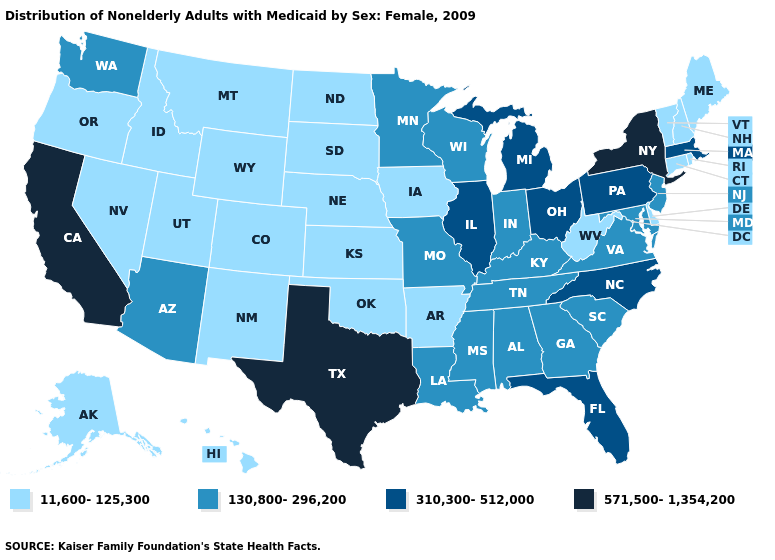What is the highest value in the USA?
Short answer required. 571,500-1,354,200. What is the lowest value in the USA?
Be succinct. 11,600-125,300. What is the value of Delaware?
Answer briefly. 11,600-125,300. Name the states that have a value in the range 11,600-125,300?
Keep it brief. Alaska, Arkansas, Colorado, Connecticut, Delaware, Hawaii, Idaho, Iowa, Kansas, Maine, Montana, Nebraska, Nevada, New Hampshire, New Mexico, North Dakota, Oklahoma, Oregon, Rhode Island, South Dakota, Utah, Vermont, West Virginia, Wyoming. Among the states that border Oklahoma , does Arkansas have the highest value?
Answer briefly. No. Which states have the highest value in the USA?
Give a very brief answer. California, New York, Texas. What is the value of New Hampshire?
Quick response, please. 11,600-125,300. Does Minnesota have the same value as South Carolina?
Write a very short answer. Yes. Name the states that have a value in the range 11,600-125,300?
Give a very brief answer. Alaska, Arkansas, Colorado, Connecticut, Delaware, Hawaii, Idaho, Iowa, Kansas, Maine, Montana, Nebraska, Nevada, New Hampshire, New Mexico, North Dakota, Oklahoma, Oregon, Rhode Island, South Dakota, Utah, Vermont, West Virginia, Wyoming. Does Illinois have the highest value in the MidWest?
Answer briefly. Yes. Which states have the highest value in the USA?
Answer briefly. California, New York, Texas. What is the value of Washington?
Keep it brief. 130,800-296,200. What is the highest value in states that border Rhode Island?
Keep it brief. 310,300-512,000. What is the value of Tennessee?
Write a very short answer. 130,800-296,200. What is the highest value in states that border Virginia?
Concise answer only. 310,300-512,000. 